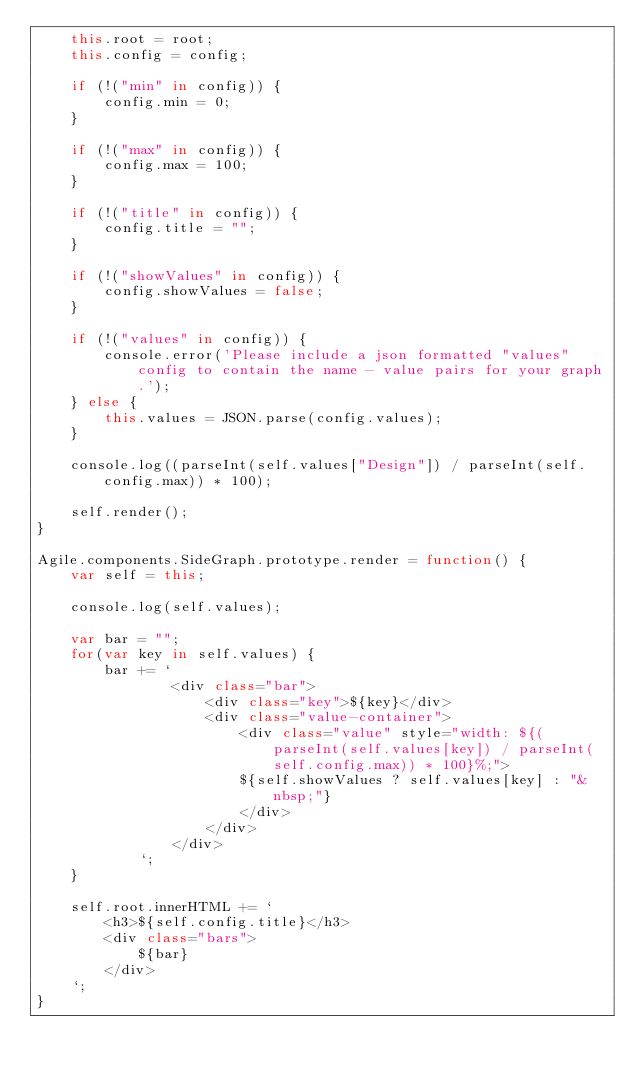<code> <loc_0><loc_0><loc_500><loc_500><_JavaScript_>    this.root = root;
    this.config = config;

    if (!("min" in config)) {
        config.min = 0;
    }

    if (!("max" in config)) {
        config.max = 100;
    }

    if (!("title" in config)) {
        config.title = "";
    }

    if (!("showValues" in config)) {
        config.showValues = false;
    }

    if (!("values" in config)) {
        console.error('Please include a json formatted "values" config to contain the name - value pairs for your graph.');
    } else {
        this.values = JSON.parse(config.values);
    }

    console.log((parseInt(self.values["Design"]) / parseInt(self.config.max)) * 100);

    self.render();
}

Agile.components.SideGraph.prototype.render = function() {
    var self = this;

    console.log(self.values);

    var bar = "";
    for(var key in self.values) {
        bar += `
                <div class="bar">
                    <div class="key">${key}</div>
                    <div class="value-container">
                        <div class="value" style="width: ${(parseInt(self.values[key]) / parseInt(self.config.max)) * 100}%;">
                        ${self.showValues ? self.values[key] : "&nbsp;"}
                        </div>
                    </div>
                </div>
            `;
    }

    self.root.innerHTML += `
        <h3>${self.config.title}</h3>
        <div class="bars">
            ${bar}
        </div>
    `;
}</code> 